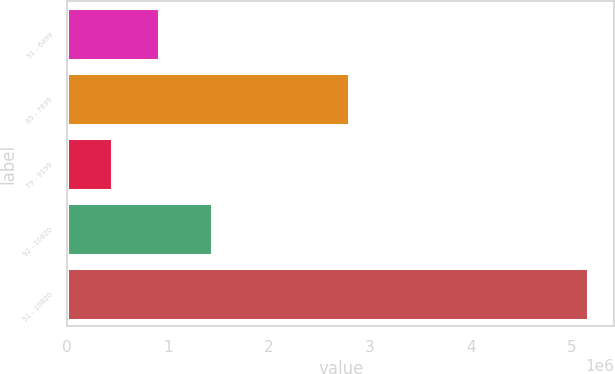<chart> <loc_0><loc_0><loc_500><loc_500><bar_chart><fcel>51 - 6499<fcel>65 - 7899<fcel>79 - 9199<fcel>92 - 10820<fcel>51 - 10820<nl><fcel>913385<fcel>2.79004e+06<fcel>441000<fcel>1.4311e+06<fcel>5.16485e+06<nl></chart> 